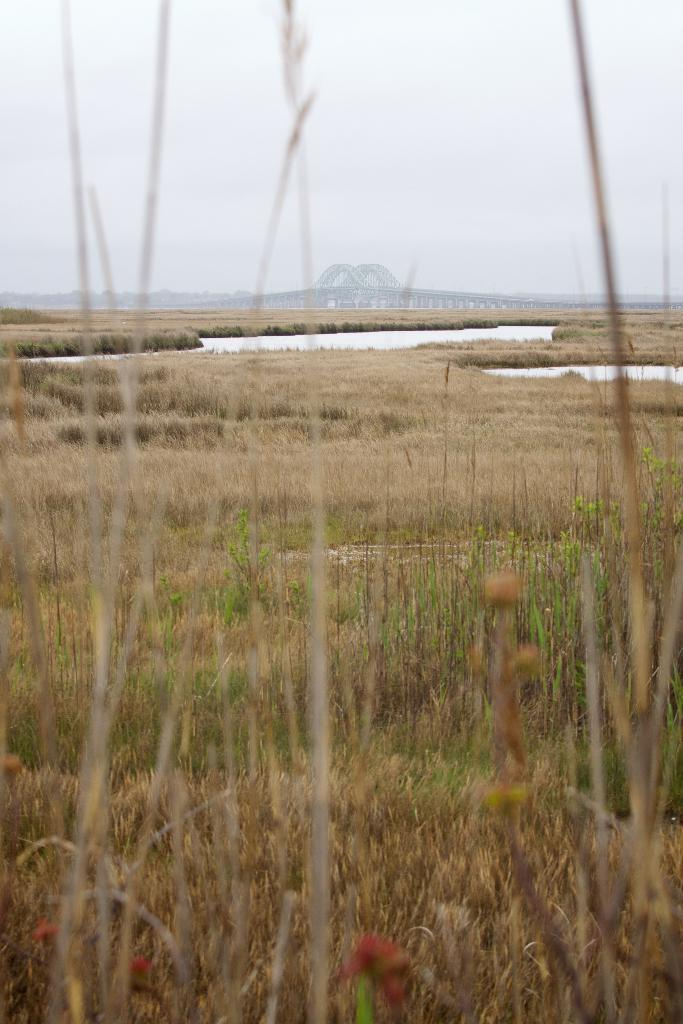What type of vegetation is visible in the front of the image? There is dry grass in the front of the image. What type of structure can be seen in the background of the image? There is a bridge in the background of the image. What is the condition of the sky in the image? The sky is cloudy in the image. Where is the playground located in the image? There is no playground present in the image. What type of glass is used to construct the bridge in the image? There is no mention of glass being used in the construction of the bridge in the image. 